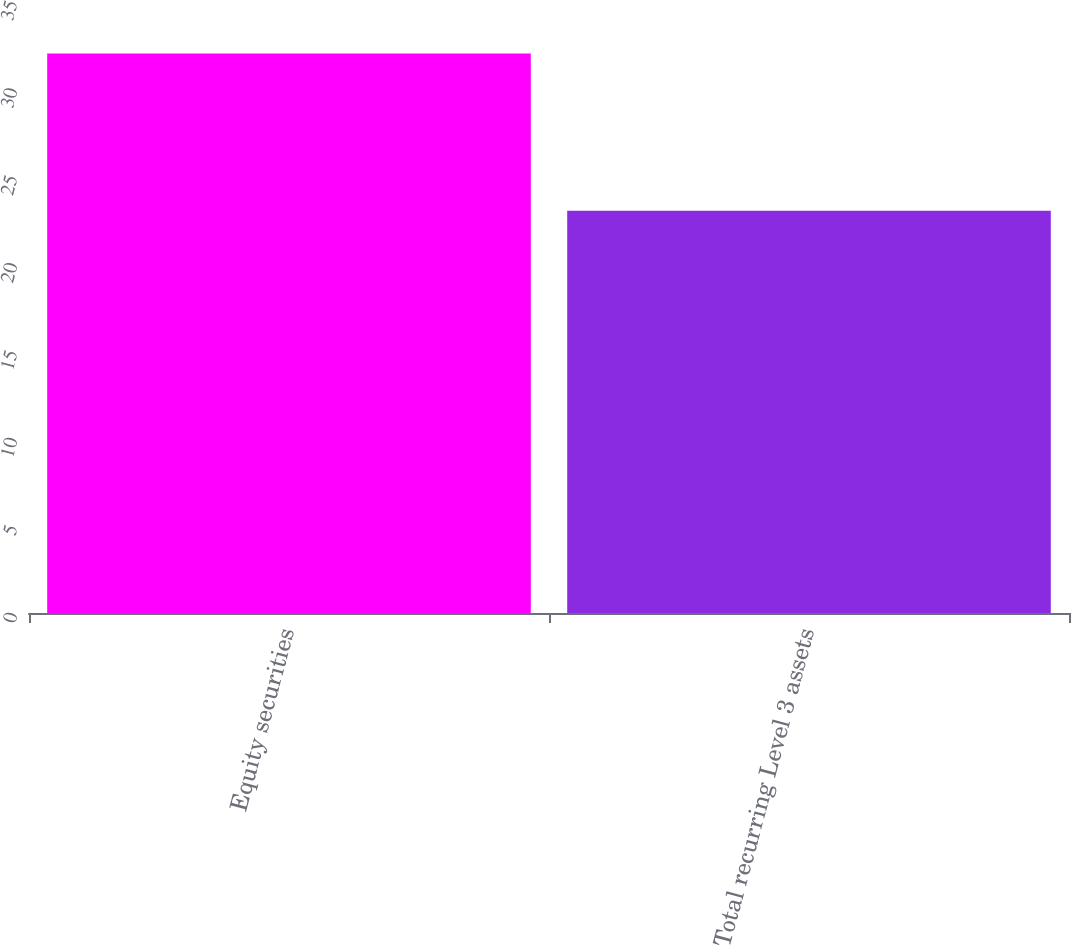Convert chart to OTSL. <chart><loc_0><loc_0><loc_500><loc_500><bar_chart><fcel>Equity securities<fcel>Total recurring Level 3 assets<nl><fcel>32<fcel>23<nl></chart> 